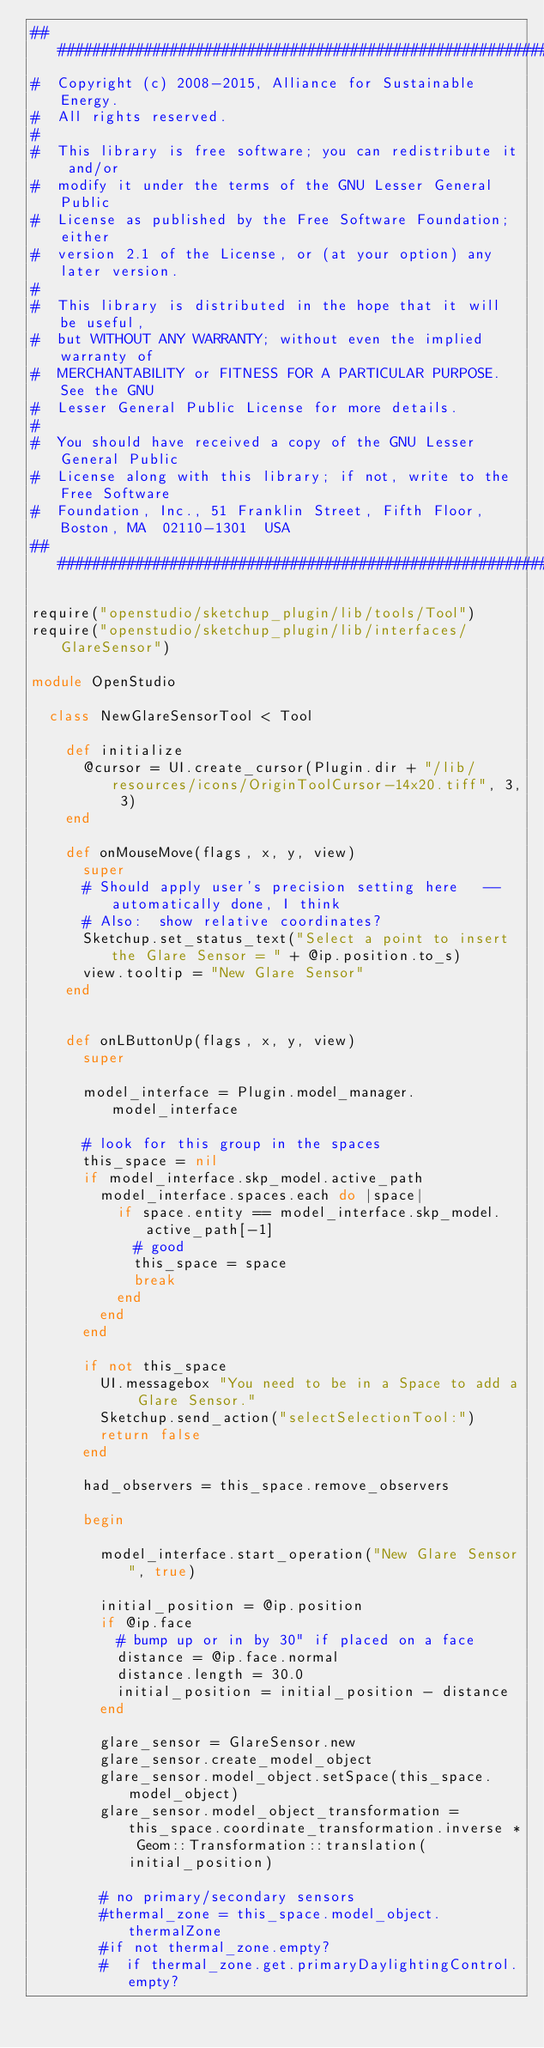<code> <loc_0><loc_0><loc_500><loc_500><_Ruby_>######################################################################
#  Copyright (c) 2008-2015, Alliance for Sustainable Energy.  
#  All rights reserved.
#  
#  This library is free software; you can redistribute it and/or
#  modify it under the terms of the GNU Lesser General Public
#  License as published by the Free Software Foundation; either
#  version 2.1 of the License, or (at your option) any later version.
#  
#  This library is distributed in the hope that it will be useful,
#  but WITHOUT ANY WARRANTY; without even the implied warranty of
#  MERCHANTABILITY or FITNESS FOR A PARTICULAR PURPOSE.  See the GNU
#  Lesser General Public License for more details.
#  
#  You should have received a copy of the GNU Lesser General Public
#  License along with this library; if not, write to the Free Software
#  Foundation, Inc., 51 Franklin Street, Fifth Floor, Boston, MA  02110-1301  USA
######################################################################

require("openstudio/sketchup_plugin/lib/tools/Tool")
require("openstudio/sketchup_plugin/lib/interfaces/GlareSensor")

module OpenStudio

  class NewGlareSensorTool < Tool
  
    def initialize
      @cursor = UI.create_cursor(Plugin.dir + "/lib/resources/icons/OriginToolCursor-14x20.tiff", 3, 3)
    end
    
    def onMouseMove(flags, x, y, view)
      super
      # Should apply user's precision setting here   --automatically done, I think
      # Also:  show relative coordinates?
      Sketchup.set_status_text("Select a point to insert the Glare Sensor = " + @ip.position.to_s)
      view.tooltip = "New Glare Sensor"
    end


    def onLButtonUp(flags, x, y, view)
      super

      model_interface = Plugin.model_manager.model_interface

      # look for this group in the spaces
      this_space = nil
      if model_interface.skp_model.active_path
        model_interface.spaces.each do |space|
          if space.entity == model_interface.skp_model.active_path[-1]
            # good
            this_space = space
            break
          end
        end
      end

      if not this_space
        UI.messagebox "You need to be in a Space to add a Glare Sensor."
        Sketchup.send_action("selectSelectionTool:")
        return false
      end
      
      had_observers = this_space.remove_observers

      begin
      
        model_interface.start_operation("New Glare Sensor", true)

        initial_position = @ip.position
        if @ip.face
          # bump up or in by 30" if placed on a face
          distance = @ip.face.normal
          distance.length = 30.0
          initial_position = initial_position - distance
        end

        glare_sensor = GlareSensor.new
        glare_sensor.create_model_object
        glare_sensor.model_object.setSpace(this_space.model_object)
        glare_sensor.model_object_transformation = this_space.coordinate_transformation.inverse * Geom::Transformation::translation(initial_position)

        # no primary/secondary sensors
        #thermal_zone = this_space.model_object.thermalZone
        #if not thermal_zone.empty?
        #  if thermal_zone.get.primaryDaylightingControl.empty?</code> 